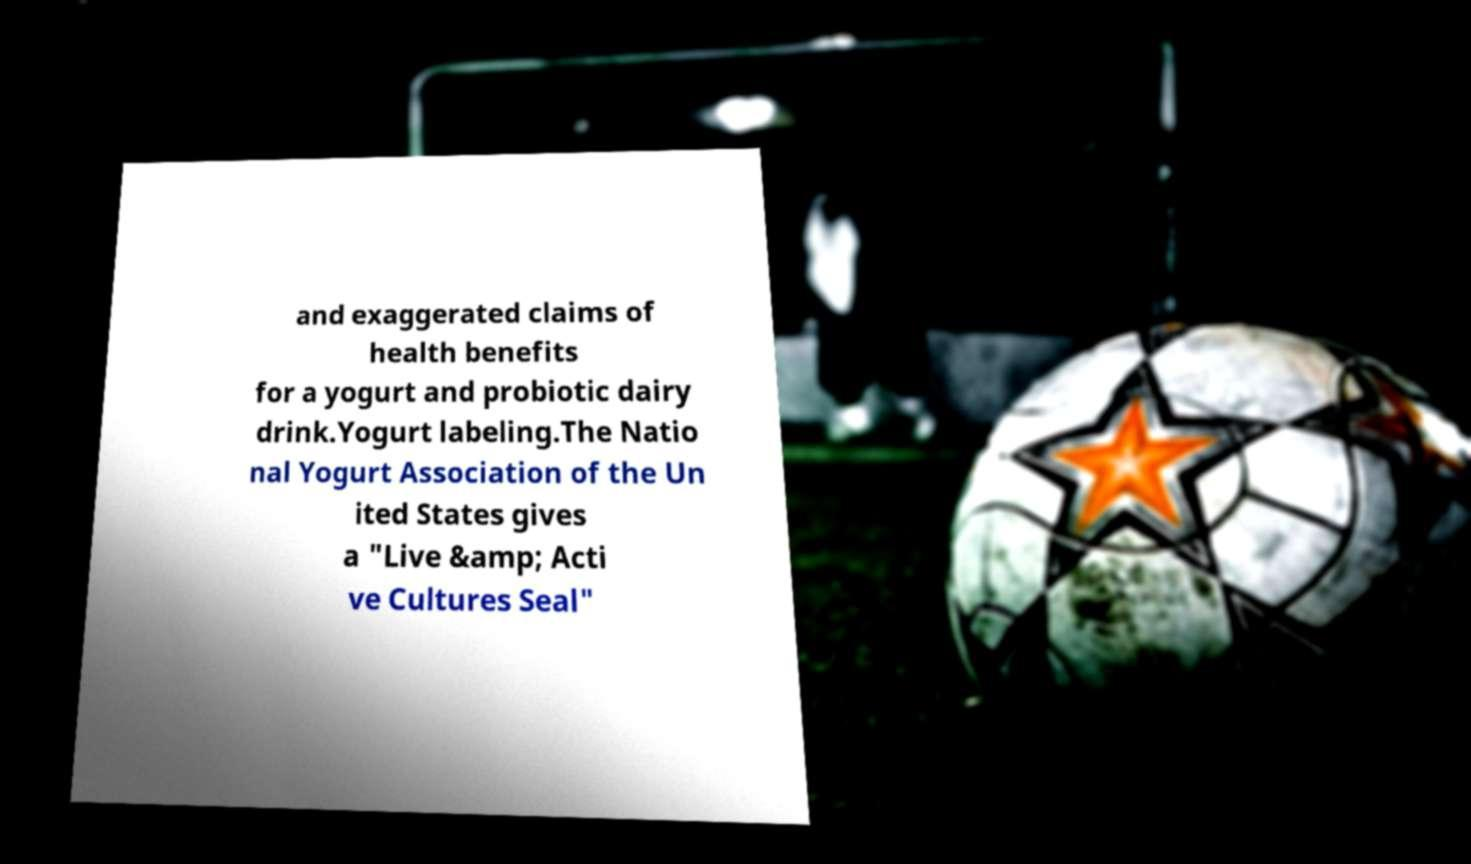Please read and relay the text visible in this image. What does it say? and exaggerated claims of health benefits for a yogurt and probiotic dairy drink.Yogurt labeling.The Natio nal Yogurt Association of the Un ited States gives a "Live &amp; Acti ve Cultures Seal" 